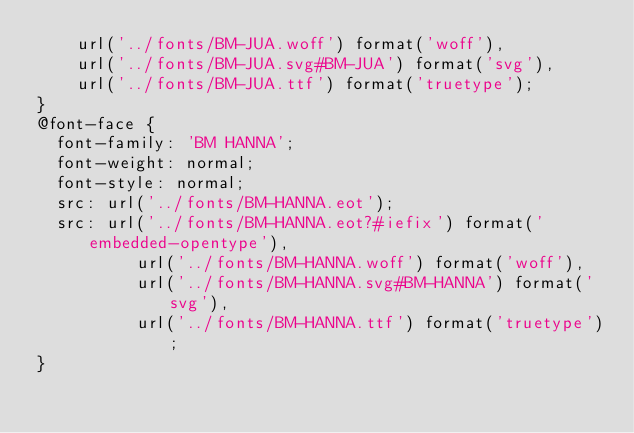Convert code to text. <code><loc_0><loc_0><loc_500><loc_500><_CSS_>		url('../fonts/BM-JUA.woff') format('woff'),
		url('../fonts/BM-JUA.svg#BM-JUA') format('svg'),
		url('../fonts/BM-JUA.ttf') format('truetype');
}
@font-face {
	font-family: 'BM HANNA';
	font-weight: normal;
	font-style: normal;
	src: url('../fonts/BM-HANNA.eot');
	src: url('../fonts/BM-HANNA.eot?#iefix') format('embedded-opentype'),
	        url('../fonts/BM-HANNA.woff') format('woff'),
	        url('../fonts/BM-HANNA.svg#BM-HANNA') format('svg'),
	        url('../fonts/BM-HANNA.ttf') format('truetype');
}
</code> 